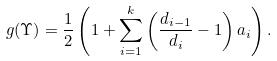Convert formula to latex. <formula><loc_0><loc_0><loc_500><loc_500>g ( \Upsilon ) = \frac { 1 } { 2 } \left ( 1 + \sum _ { i = 1 } ^ { k } \left ( \frac { d _ { i - 1 } } { d _ { i } } - 1 \right ) a _ { i } \right ) .</formula> 